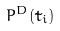<formula> <loc_0><loc_0><loc_500><loc_500>P ^ { D } ( \tilde { t } _ { i } )</formula> 